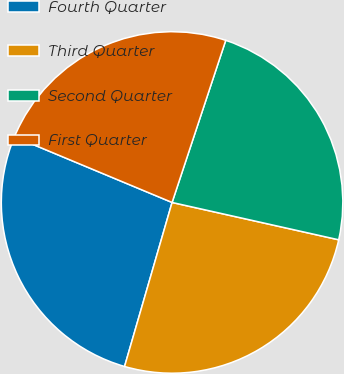Convert chart. <chart><loc_0><loc_0><loc_500><loc_500><pie_chart><fcel>Fourth Quarter<fcel>Third Quarter<fcel>Second Quarter<fcel>First Quarter<nl><fcel>26.8%<fcel>25.98%<fcel>23.42%<fcel>23.8%<nl></chart> 